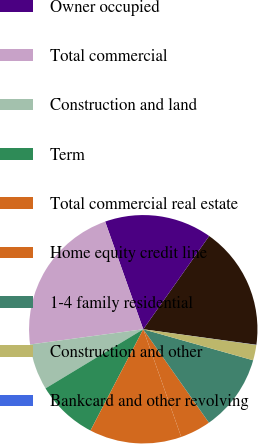Convert chart. <chart><loc_0><loc_0><loc_500><loc_500><pie_chart><fcel>Commercial and industrial<fcel>Owner occupied<fcel>Total commercial<fcel>Construction and land<fcel>Term<fcel>Total commercial real estate<fcel>Home equity credit line<fcel>1-4 family residential<fcel>Construction and other<fcel>Bankcard and other revolving<nl><fcel>17.38%<fcel>15.21%<fcel>21.72%<fcel>6.53%<fcel>8.7%<fcel>13.04%<fcel>4.36%<fcel>10.87%<fcel>2.19%<fcel>0.02%<nl></chart> 